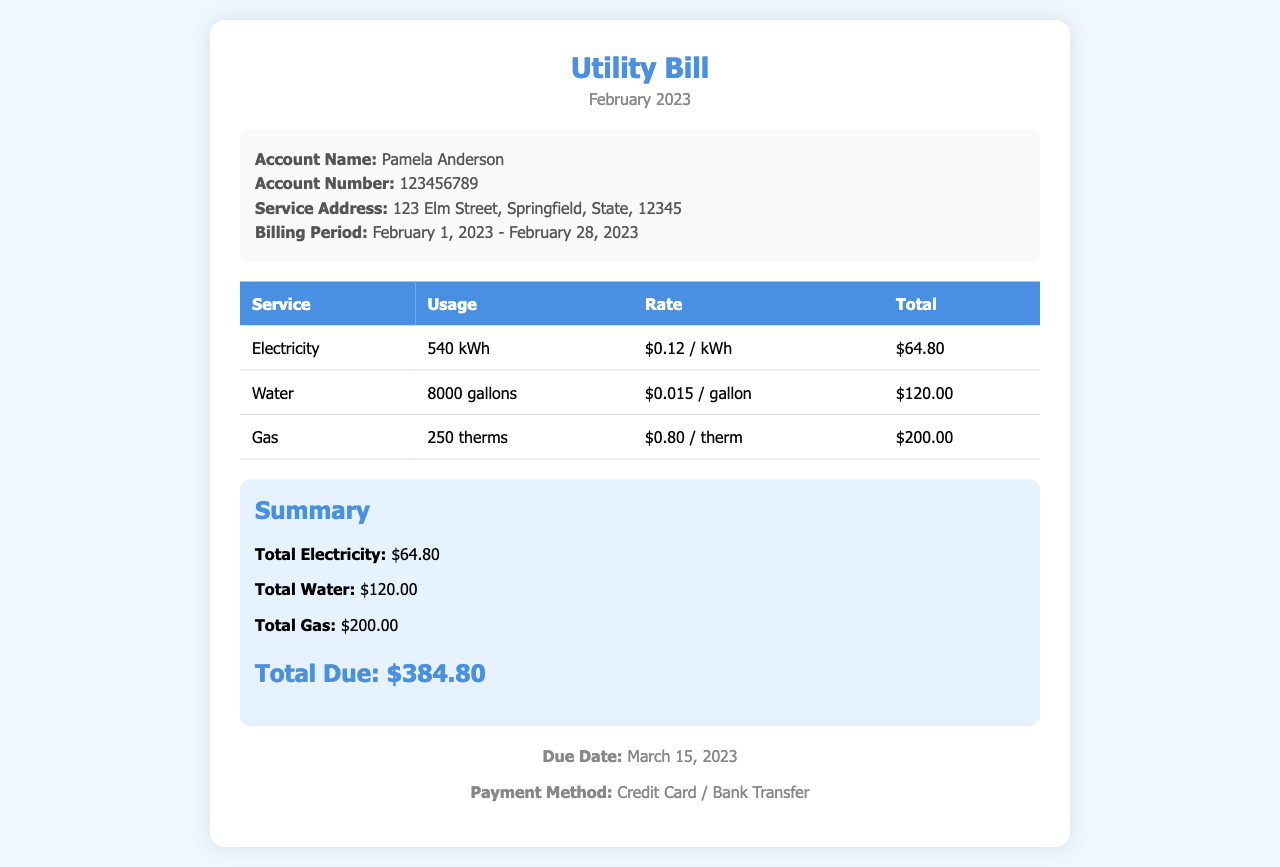What is the account name? The account name is mentioned in the account details section of the document as Pamela Anderson.
Answer: Pamela Anderson What is the total due amount? The total due amount is found in the summary section where the total is calculated as the sum of all individual services.
Answer: $384.80 What is the service address? The service address is specified in the account details section of the document.
Answer: 123 Elm Street, Springfield, State, 12345 How much was charged for gas? The charge for gas is detailed in the table under the gas service.
Answer: $200.00 What is the billing period? The billing period is outlined in the account details and specifies the duration for which the charges apply.
Answer: February 1, 2023 - February 28, 2023 What is the total water usage? The total water usage is mentioned in the table under the water service category.
Answer: 8000 gallons What date is the payment due? The due date for the payment is clearly stated in the footer of the document.
Answer: March 15, 2023 How many therms of gas were used? The number of therms used is provided in the table under the gas service entry.
Answer: 250 therms What is the rate per kilowatt-hour for electricity? The rate for electricity is specified in the table along with the electrical service details.
Answer: $0.12 / kWh 